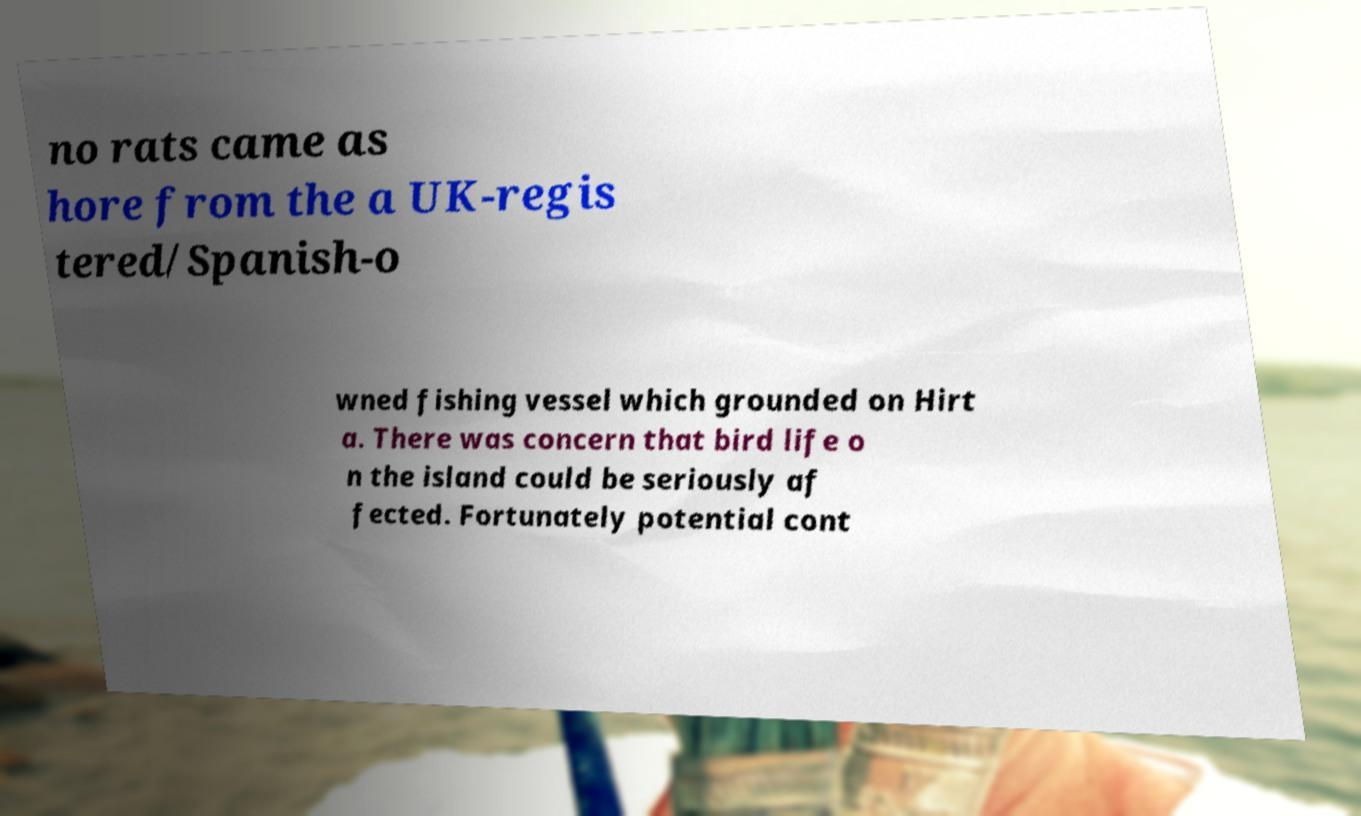Please identify and transcribe the text found in this image. no rats came as hore from the a UK-regis tered/Spanish-o wned fishing vessel which grounded on Hirt a. There was concern that bird life o n the island could be seriously af fected. Fortunately potential cont 